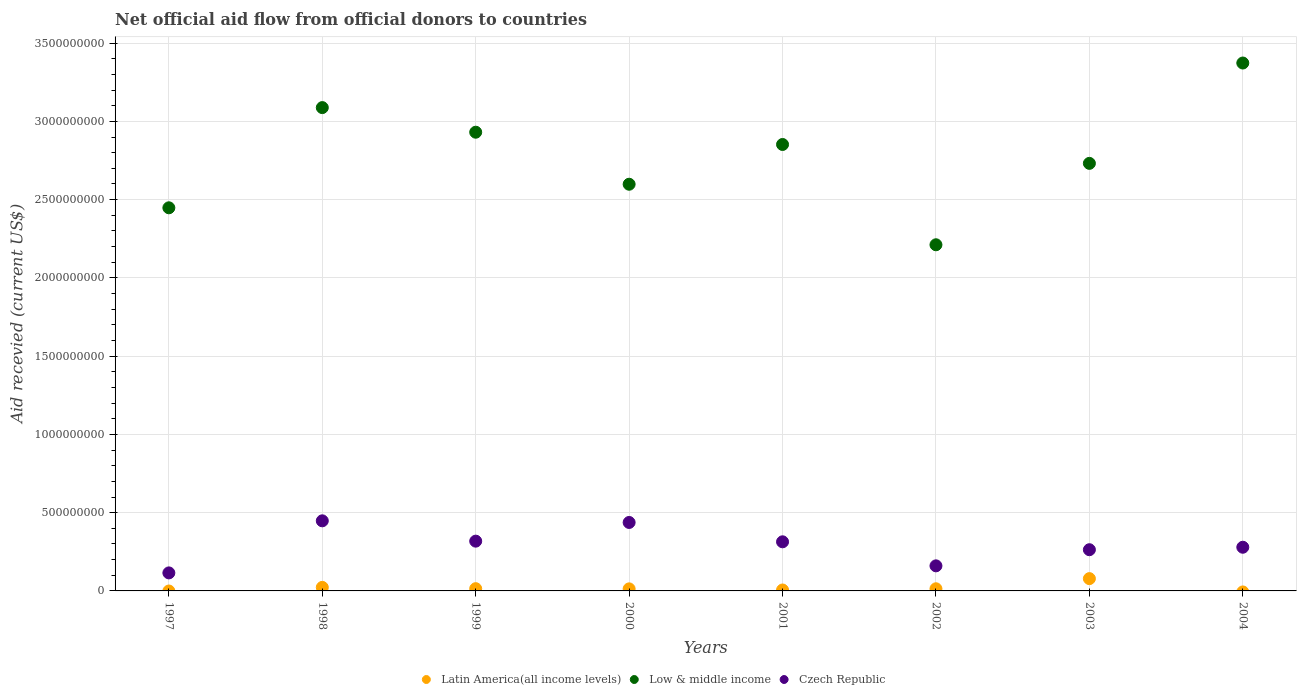How many different coloured dotlines are there?
Your answer should be compact. 3. Is the number of dotlines equal to the number of legend labels?
Your response must be concise. No. What is the total aid received in Low & middle income in 1998?
Provide a short and direct response. 3.09e+09. Across all years, what is the maximum total aid received in Low & middle income?
Make the answer very short. 3.37e+09. Across all years, what is the minimum total aid received in Czech Republic?
Give a very brief answer. 1.15e+08. In which year was the total aid received in Latin America(all income levels) maximum?
Offer a terse response. 2003. What is the total total aid received in Low & middle income in the graph?
Your response must be concise. 2.22e+1. What is the difference between the total aid received in Czech Republic in 1997 and that in 2003?
Your answer should be compact. -1.48e+08. What is the difference between the total aid received in Czech Republic in 2003 and the total aid received in Latin America(all income levels) in 1997?
Your answer should be very brief. 2.63e+08. What is the average total aid received in Czech Republic per year?
Ensure brevity in your answer.  2.92e+08. In the year 1998, what is the difference between the total aid received in Czech Republic and total aid received in Low & middle income?
Offer a very short reply. -2.64e+09. In how many years, is the total aid received in Low & middle income greater than 1800000000 US$?
Ensure brevity in your answer.  8. What is the ratio of the total aid received in Low & middle income in 2001 to that in 2002?
Your answer should be very brief. 1.29. Is the difference between the total aid received in Czech Republic in 1999 and 2000 greater than the difference between the total aid received in Low & middle income in 1999 and 2000?
Offer a very short reply. No. What is the difference between the highest and the second highest total aid received in Czech Republic?
Give a very brief answer. 1.05e+07. What is the difference between the highest and the lowest total aid received in Low & middle income?
Provide a short and direct response. 1.16e+09. In how many years, is the total aid received in Czech Republic greater than the average total aid received in Czech Republic taken over all years?
Provide a short and direct response. 4. Is the total aid received in Czech Republic strictly greater than the total aid received in Latin America(all income levels) over the years?
Provide a succinct answer. Yes. Is the total aid received in Czech Republic strictly less than the total aid received in Low & middle income over the years?
Give a very brief answer. Yes. Does the graph contain grids?
Your answer should be compact. Yes. Where does the legend appear in the graph?
Provide a short and direct response. Bottom center. What is the title of the graph?
Give a very brief answer. Net official aid flow from official donors to countries. Does "Kazakhstan" appear as one of the legend labels in the graph?
Keep it short and to the point. No. What is the label or title of the Y-axis?
Your response must be concise. Aid recevied (current US$). What is the Aid recevied (current US$) in Latin America(all income levels) in 1997?
Give a very brief answer. 0. What is the Aid recevied (current US$) in Low & middle income in 1997?
Ensure brevity in your answer.  2.45e+09. What is the Aid recevied (current US$) in Czech Republic in 1997?
Offer a terse response. 1.15e+08. What is the Aid recevied (current US$) of Latin America(all income levels) in 1998?
Your response must be concise. 2.25e+07. What is the Aid recevied (current US$) of Low & middle income in 1998?
Your answer should be very brief. 3.09e+09. What is the Aid recevied (current US$) of Czech Republic in 1998?
Ensure brevity in your answer.  4.48e+08. What is the Aid recevied (current US$) in Latin America(all income levels) in 1999?
Your answer should be compact. 1.43e+07. What is the Aid recevied (current US$) of Low & middle income in 1999?
Your answer should be compact. 2.93e+09. What is the Aid recevied (current US$) in Czech Republic in 1999?
Provide a short and direct response. 3.18e+08. What is the Aid recevied (current US$) in Latin America(all income levels) in 2000?
Give a very brief answer. 1.31e+07. What is the Aid recevied (current US$) of Low & middle income in 2000?
Your response must be concise. 2.60e+09. What is the Aid recevied (current US$) in Czech Republic in 2000?
Your response must be concise. 4.37e+08. What is the Aid recevied (current US$) in Latin America(all income levels) in 2001?
Offer a terse response. 5.97e+06. What is the Aid recevied (current US$) in Low & middle income in 2001?
Ensure brevity in your answer.  2.85e+09. What is the Aid recevied (current US$) of Czech Republic in 2001?
Keep it short and to the point. 3.14e+08. What is the Aid recevied (current US$) of Latin America(all income levels) in 2002?
Your answer should be very brief. 1.37e+07. What is the Aid recevied (current US$) in Low & middle income in 2002?
Keep it short and to the point. 2.21e+09. What is the Aid recevied (current US$) in Czech Republic in 2002?
Keep it short and to the point. 1.60e+08. What is the Aid recevied (current US$) of Latin America(all income levels) in 2003?
Offer a terse response. 7.86e+07. What is the Aid recevied (current US$) in Low & middle income in 2003?
Your answer should be compact. 2.73e+09. What is the Aid recevied (current US$) in Czech Republic in 2003?
Your response must be concise. 2.63e+08. What is the Aid recevied (current US$) in Latin America(all income levels) in 2004?
Your response must be concise. 0. What is the Aid recevied (current US$) of Low & middle income in 2004?
Offer a very short reply. 3.37e+09. What is the Aid recevied (current US$) in Czech Republic in 2004?
Offer a terse response. 2.79e+08. Across all years, what is the maximum Aid recevied (current US$) of Latin America(all income levels)?
Make the answer very short. 7.86e+07. Across all years, what is the maximum Aid recevied (current US$) in Low & middle income?
Give a very brief answer. 3.37e+09. Across all years, what is the maximum Aid recevied (current US$) in Czech Republic?
Your answer should be very brief. 4.48e+08. Across all years, what is the minimum Aid recevied (current US$) of Low & middle income?
Provide a short and direct response. 2.21e+09. Across all years, what is the minimum Aid recevied (current US$) in Czech Republic?
Keep it short and to the point. 1.15e+08. What is the total Aid recevied (current US$) in Latin America(all income levels) in the graph?
Give a very brief answer. 1.48e+08. What is the total Aid recevied (current US$) in Low & middle income in the graph?
Your answer should be compact. 2.22e+1. What is the total Aid recevied (current US$) in Czech Republic in the graph?
Your response must be concise. 2.33e+09. What is the difference between the Aid recevied (current US$) in Low & middle income in 1997 and that in 1998?
Offer a terse response. -6.40e+08. What is the difference between the Aid recevied (current US$) of Czech Republic in 1997 and that in 1998?
Offer a terse response. -3.33e+08. What is the difference between the Aid recevied (current US$) in Low & middle income in 1997 and that in 1999?
Keep it short and to the point. -4.83e+08. What is the difference between the Aid recevied (current US$) of Czech Republic in 1997 and that in 1999?
Offer a terse response. -2.03e+08. What is the difference between the Aid recevied (current US$) in Low & middle income in 1997 and that in 2000?
Offer a terse response. -1.50e+08. What is the difference between the Aid recevied (current US$) of Czech Republic in 1997 and that in 2000?
Provide a succinct answer. -3.22e+08. What is the difference between the Aid recevied (current US$) in Low & middle income in 1997 and that in 2001?
Provide a succinct answer. -4.04e+08. What is the difference between the Aid recevied (current US$) of Czech Republic in 1997 and that in 2001?
Provide a succinct answer. -1.99e+08. What is the difference between the Aid recevied (current US$) in Low & middle income in 1997 and that in 2002?
Give a very brief answer. 2.36e+08. What is the difference between the Aid recevied (current US$) of Czech Republic in 1997 and that in 2002?
Give a very brief answer. -4.51e+07. What is the difference between the Aid recevied (current US$) of Low & middle income in 1997 and that in 2003?
Provide a short and direct response. -2.84e+08. What is the difference between the Aid recevied (current US$) of Czech Republic in 1997 and that in 2003?
Your response must be concise. -1.48e+08. What is the difference between the Aid recevied (current US$) in Low & middle income in 1997 and that in 2004?
Your response must be concise. -9.25e+08. What is the difference between the Aid recevied (current US$) in Czech Republic in 1997 and that in 2004?
Keep it short and to the point. -1.64e+08. What is the difference between the Aid recevied (current US$) in Latin America(all income levels) in 1998 and that in 1999?
Your answer should be compact. 8.20e+06. What is the difference between the Aid recevied (current US$) in Low & middle income in 1998 and that in 1999?
Ensure brevity in your answer.  1.57e+08. What is the difference between the Aid recevied (current US$) in Czech Republic in 1998 and that in 1999?
Provide a succinct answer. 1.30e+08. What is the difference between the Aid recevied (current US$) in Latin America(all income levels) in 1998 and that in 2000?
Provide a succinct answer. 9.40e+06. What is the difference between the Aid recevied (current US$) in Low & middle income in 1998 and that in 2000?
Your answer should be very brief. 4.90e+08. What is the difference between the Aid recevied (current US$) of Czech Republic in 1998 and that in 2000?
Make the answer very short. 1.05e+07. What is the difference between the Aid recevied (current US$) of Latin America(all income levels) in 1998 and that in 2001?
Offer a terse response. 1.66e+07. What is the difference between the Aid recevied (current US$) of Low & middle income in 1998 and that in 2001?
Your response must be concise. 2.36e+08. What is the difference between the Aid recevied (current US$) in Czech Republic in 1998 and that in 2001?
Make the answer very short. 1.34e+08. What is the difference between the Aid recevied (current US$) of Latin America(all income levels) in 1998 and that in 2002?
Make the answer very short. 8.82e+06. What is the difference between the Aid recevied (current US$) in Low & middle income in 1998 and that in 2002?
Give a very brief answer. 8.76e+08. What is the difference between the Aid recevied (current US$) of Czech Republic in 1998 and that in 2002?
Your answer should be very brief. 2.88e+08. What is the difference between the Aid recevied (current US$) in Latin America(all income levels) in 1998 and that in 2003?
Keep it short and to the point. -5.60e+07. What is the difference between the Aid recevied (current US$) in Low & middle income in 1998 and that in 2003?
Your answer should be compact. 3.56e+08. What is the difference between the Aid recevied (current US$) of Czech Republic in 1998 and that in 2003?
Your answer should be very brief. 1.85e+08. What is the difference between the Aid recevied (current US$) of Low & middle income in 1998 and that in 2004?
Keep it short and to the point. -2.85e+08. What is the difference between the Aid recevied (current US$) of Czech Republic in 1998 and that in 2004?
Your response must be concise. 1.69e+08. What is the difference between the Aid recevied (current US$) of Latin America(all income levels) in 1999 and that in 2000?
Ensure brevity in your answer.  1.20e+06. What is the difference between the Aid recevied (current US$) in Low & middle income in 1999 and that in 2000?
Your response must be concise. 3.32e+08. What is the difference between the Aid recevied (current US$) of Czech Republic in 1999 and that in 2000?
Offer a very short reply. -1.19e+08. What is the difference between the Aid recevied (current US$) of Latin America(all income levels) in 1999 and that in 2001?
Offer a very short reply. 8.36e+06. What is the difference between the Aid recevied (current US$) in Low & middle income in 1999 and that in 2001?
Make the answer very short. 7.84e+07. What is the difference between the Aid recevied (current US$) of Czech Republic in 1999 and that in 2001?
Provide a succinct answer. 4.21e+06. What is the difference between the Aid recevied (current US$) of Latin America(all income levels) in 1999 and that in 2002?
Keep it short and to the point. 6.20e+05. What is the difference between the Aid recevied (current US$) in Low & middle income in 1999 and that in 2002?
Provide a succinct answer. 7.19e+08. What is the difference between the Aid recevied (current US$) of Czech Republic in 1999 and that in 2002?
Provide a short and direct response. 1.58e+08. What is the difference between the Aid recevied (current US$) of Latin America(all income levels) in 1999 and that in 2003?
Make the answer very short. -6.42e+07. What is the difference between the Aid recevied (current US$) in Low & middle income in 1999 and that in 2003?
Make the answer very short. 1.99e+08. What is the difference between the Aid recevied (current US$) of Czech Republic in 1999 and that in 2003?
Your response must be concise. 5.47e+07. What is the difference between the Aid recevied (current US$) in Low & middle income in 1999 and that in 2004?
Make the answer very short. -4.42e+08. What is the difference between the Aid recevied (current US$) of Czech Republic in 1999 and that in 2004?
Keep it short and to the point. 3.89e+07. What is the difference between the Aid recevied (current US$) in Latin America(all income levels) in 2000 and that in 2001?
Ensure brevity in your answer.  7.16e+06. What is the difference between the Aid recevied (current US$) of Low & middle income in 2000 and that in 2001?
Make the answer very short. -2.54e+08. What is the difference between the Aid recevied (current US$) of Czech Republic in 2000 and that in 2001?
Your answer should be compact. 1.24e+08. What is the difference between the Aid recevied (current US$) of Latin America(all income levels) in 2000 and that in 2002?
Your answer should be compact. -5.80e+05. What is the difference between the Aid recevied (current US$) of Low & middle income in 2000 and that in 2002?
Your answer should be very brief. 3.87e+08. What is the difference between the Aid recevied (current US$) of Czech Republic in 2000 and that in 2002?
Provide a succinct answer. 2.77e+08. What is the difference between the Aid recevied (current US$) of Latin America(all income levels) in 2000 and that in 2003?
Give a very brief answer. -6.54e+07. What is the difference between the Aid recevied (current US$) in Low & middle income in 2000 and that in 2003?
Your answer should be compact. -1.33e+08. What is the difference between the Aid recevied (current US$) in Czech Republic in 2000 and that in 2003?
Ensure brevity in your answer.  1.74e+08. What is the difference between the Aid recevied (current US$) in Low & middle income in 2000 and that in 2004?
Offer a very short reply. -7.74e+08. What is the difference between the Aid recevied (current US$) in Czech Republic in 2000 and that in 2004?
Your answer should be very brief. 1.58e+08. What is the difference between the Aid recevied (current US$) in Latin America(all income levels) in 2001 and that in 2002?
Give a very brief answer. -7.74e+06. What is the difference between the Aid recevied (current US$) in Low & middle income in 2001 and that in 2002?
Your response must be concise. 6.41e+08. What is the difference between the Aid recevied (current US$) of Czech Republic in 2001 and that in 2002?
Offer a terse response. 1.54e+08. What is the difference between the Aid recevied (current US$) in Latin America(all income levels) in 2001 and that in 2003?
Provide a short and direct response. -7.26e+07. What is the difference between the Aid recevied (current US$) of Low & middle income in 2001 and that in 2003?
Provide a succinct answer. 1.21e+08. What is the difference between the Aid recevied (current US$) of Czech Republic in 2001 and that in 2003?
Your answer should be very brief. 5.05e+07. What is the difference between the Aid recevied (current US$) in Low & middle income in 2001 and that in 2004?
Ensure brevity in your answer.  -5.20e+08. What is the difference between the Aid recevied (current US$) in Czech Republic in 2001 and that in 2004?
Ensure brevity in your answer.  3.47e+07. What is the difference between the Aid recevied (current US$) in Latin America(all income levels) in 2002 and that in 2003?
Offer a terse response. -6.49e+07. What is the difference between the Aid recevied (current US$) of Low & middle income in 2002 and that in 2003?
Your answer should be very brief. -5.20e+08. What is the difference between the Aid recevied (current US$) in Czech Republic in 2002 and that in 2003?
Offer a terse response. -1.03e+08. What is the difference between the Aid recevied (current US$) of Low & middle income in 2002 and that in 2004?
Offer a terse response. -1.16e+09. What is the difference between the Aid recevied (current US$) of Czech Republic in 2002 and that in 2004?
Give a very brief answer. -1.19e+08. What is the difference between the Aid recevied (current US$) of Low & middle income in 2003 and that in 2004?
Your answer should be compact. -6.41e+08. What is the difference between the Aid recevied (current US$) of Czech Republic in 2003 and that in 2004?
Your response must be concise. -1.58e+07. What is the difference between the Aid recevied (current US$) in Low & middle income in 1997 and the Aid recevied (current US$) in Czech Republic in 1998?
Offer a terse response. 2.00e+09. What is the difference between the Aid recevied (current US$) in Low & middle income in 1997 and the Aid recevied (current US$) in Czech Republic in 1999?
Keep it short and to the point. 2.13e+09. What is the difference between the Aid recevied (current US$) in Low & middle income in 1997 and the Aid recevied (current US$) in Czech Republic in 2000?
Your answer should be very brief. 2.01e+09. What is the difference between the Aid recevied (current US$) of Low & middle income in 1997 and the Aid recevied (current US$) of Czech Republic in 2001?
Give a very brief answer. 2.13e+09. What is the difference between the Aid recevied (current US$) of Low & middle income in 1997 and the Aid recevied (current US$) of Czech Republic in 2002?
Offer a terse response. 2.29e+09. What is the difference between the Aid recevied (current US$) in Low & middle income in 1997 and the Aid recevied (current US$) in Czech Republic in 2003?
Offer a very short reply. 2.18e+09. What is the difference between the Aid recevied (current US$) in Low & middle income in 1997 and the Aid recevied (current US$) in Czech Republic in 2004?
Make the answer very short. 2.17e+09. What is the difference between the Aid recevied (current US$) in Latin America(all income levels) in 1998 and the Aid recevied (current US$) in Low & middle income in 1999?
Provide a short and direct response. -2.91e+09. What is the difference between the Aid recevied (current US$) of Latin America(all income levels) in 1998 and the Aid recevied (current US$) of Czech Republic in 1999?
Ensure brevity in your answer.  -2.95e+08. What is the difference between the Aid recevied (current US$) in Low & middle income in 1998 and the Aid recevied (current US$) in Czech Republic in 1999?
Make the answer very short. 2.77e+09. What is the difference between the Aid recevied (current US$) of Latin America(all income levels) in 1998 and the Aid recevied (current US$) of Low & middle income in 2000?
Ensure brevity in your answer.  -2.58e+09. What is the difference between the Aid recevied (current US$) in Latin America(all income levels) in 1998 and the Aid recevied (current US$) in Czech Republic in 2000?
Make the answer very short. -4.15e+08. What is the difference between the Aid recevied (current US$) of Low & middle income in 1998 and the Aid recevied (current US$) of Czech Republic in 2000?
Your answer should be compact. 2.65e+09. What is the difference between the Aid recevied (current US$) in Latin America(all income levels) in 1998 and the Aid recevied (current US$) in Low & middle income in 2001?
Offer a very short reply. -2.83e+09. What is the difference between the Aid recevied (current US$) in Latin America(all income levels) in 1998 and the Aid recevied (current US$) in Czech Republic in 2001?
Give a very brief answer. -2.91e+08. What is the difference between the Aid recevied (current US$) of Low & middle income in 1998 and the Aid recevied (current US$) of Czech Republic in 2001?
Offer a very short reply. 2.77e+09. What is the difference between the Aid recevied (current US$) of Latin America(all income levels) in 1998 and the Aid recevied (current US$) of Low & middle income in 2002?
Provide a succinct answer. -2.19e+09. What is the difference between the Aid recevied (current US$) in Latin America(all income levels) in 1998 and the Aid recevied (current US$) in Czech Republic in 2002?
Make the answer very short. -1.38e+08. What is the difference between the Aid recevied (current US$) in Low & middle income in 1998 and the Aid recevied (current US$) in Czech Republic in 2002?
Your response must be concise. 2.93e+09. What is the difference between the Aid recevied (current US$) in Latin America(all income levels) in 1998 and the Aid recevied (current US$) in Low & middle income in 2003?
Make the answer very short. -2.71e+09. What is the difference between the Aid recevied (current US$) of Latin America(all income levels) in 1998 and the Aid recevied (current US$) of Czech Republic in 2003?
Keep it short and to the point. -2.41e+08. What is the difference between the Aid recevied (current US$) of Low & middle income in 1998 and the Aid recevied (current US$) of Czech Republic in 2003?
Provide a short and direct response. 2.82e+09. What is the difference between the Aid recevied (current US$) of Latin America(all income levels) in 1998 and the Aid recevied (current US$) of Low & middle income in 2004?
Your answer should be very brief. -3.35e+09. What is the difference between the Aid recevied (current US$) in Latin America(all income levels) in 1998 and the Aid recevied (current US$) in Czech Republic in 2004?
Make the answer very short. -2.57e+08. What is the difference between the Aid recevied (current US$) in Low & middle income in 1998 and the Aid recevied (current US$) in Czech Republic in 2004?
Your answer should be compact. 2.81e+09. What is the difference between the Aid recevied (current US$) of Latin America(all income levels) in 1999 and the Aid recevied (current US$) of Low & middle income in 2000?
Your response must be concise. -2.58e+09. What is the difference between the Aid recevied (current US$) in Latin America(all income levels) in 1999 and the Aid recevied (current US$) in Czech Republic in 2000?
Offer a very short reply. -4.23e+08. What is the difference between the Aid recevied (current US$) in Low & middle income in 1999 and the Aid recevied (current US$) in Czech Republic in 2000?
Offer a very short reply. 2.49e+09. What is the difference between the Aid recevied (current US$) in Latin America(all income levels) in 1999 and the Aid recevied (current US$) in Low & middle income in 2001?
Give a very brief answer. -2.84e+09. What is the difference between the Aid recevied (current US$) in Latin America(all income levels) in 1999 and the Aid recevied (current US$) in Czech Republic in 2001?
Ensure brevity in your answer.  -2.99e+08. What is the difference between the Aid recevied (current US$) of Low & middle income in 1999 and the Aid recevied (current US$) of Czech Republic in 2001?
Give a very brief answer. 2.62e+09. What is the difference between the Aid recevied (current US$) of Latin America(all income levels) in 1999 and the Aid recevied (current US$) of Low & middle income in 2002?
Ensure brevity in your answer.  -2.20e+09. What is the difference between the Aid recevied (current US$) of Latin America(all income levels) in 1999 and the Aid recevied (current US$) of Czech Republic in 2002?
Give a very brief answer. -1.46e+08. What is the difference between the Aid recevied (current US$) in Low & middle income in 1999 and the Aid recevied (current US$) in Czech Republic in 2002?
Offer a terse response. 2.77e+09. What is the difference between the Aid recevied (current US$) in Latin America(all income levels) in 1999 and the Aid recevied (current US$) in Low & middle income in 2003?
Make the answer very short. -2.72e+09. What is the difference between the Aid recevied (current US$) in Latin America(all income levels) in 1999 and the Aid recevied (current US$) in Czech Republic in 2003?
Ensure brevity in your answer.  -2.49e+08. What is the difference between the Aid recevied (current US$) in Low & middle income in 1999 and the Aid recevied (current US$) in Czech Republic in 2003?
Ensure brevity in your answer.  2.67e+09. What is the difference between the Aid recevied (current US$) in Latin America(all income levels) in 1999 and the Aid recevied (current US$) in Low & middle income in 2004?
Give a very brief answer. -3.36e+09. What is the difference between the Aid recevied (current US$) of Latin America(all income levels) in 1999 and the Aid recevied (current US$) of Czech Republic in 2004?
Make the answer very short. -2.65e+08. What is the difference between the Aid recevied (current US$) of Low & middle income in 1999 and the Aid recevied (current US$) of Czech Republic in 2004?
Provide a short and direct response. 2.65e+09. What is the difference between the Aid recevied (current US$) of Latin America(all income levels) in 2000 and the Aid recevied (current US$) of Low & middle income in 2001?
Your response must be concise. -2.84e+09. What is the difference between the Aid recevied (current US$) in Latin America(all income levels) in 2000 and the Aid recevied (current US$) in Czech Republic in 2001?
Your answer should be very brief. -3.01e+08. What is the difference between the Aid recevied (current US$) of Low & middle income in 2000 and the Aid recevied (current US$) of Czech Republic in 2001?
Keep it short and to the point. 2.28e+09. What is the difference between the Aid recevied (current US$) of Latin America(all income levels) in 2000 and the Aid recevied (current US$) of Low & middle income in 2002?
Offer a terse response. -2.20e+09. What is the difference between the Aid recevied (current US$) of Latin America(all income levels) in 2000 and the Aid recevied (current US$) of Czech Republic in 2002?
Provide a succinct answer. -1.47e+08. What is the difference between the Aid recevied (current US$) in Low & middle income in 2000 and the Aid recevied (current US$) in Czech Republic in 2002?
Provide a succinct answer. 2.44e+09. What is the difference between the Aid recevied (current US$) of Latin America(all income levels) in 2000 and the Aid recevied (current US$) of Low & middle income in 2003?
Provide a succinct answer. -2.72e+09. What is the difference between the Aid recevied (current US$) in Latin America(all income levels) in 2000 and the Aid recevied (current US$) in Czech Republic in 2003?
Make the answer very short. -2.50e+08. What is the difference between the Aid recevied (current US$) of Low & middle income in 2000 and the Aid recevied (current US$) of Czech Republic in 2003?
Your response must be concise. 2.34e+09. What is the difference between the Aid recevied (current US$) in Latin America(all income levels) in 2000 and the Aid recevied (current US$) in Low & middle income in 2004?
Give a very brief answer. -3.36e+09. What is the difference between the Aid recevied (current US$) of Latin America(all income levels) in 2000 and the Aid recevied (current US$) of Czech Republic in 2004?
Your response must be concise. -2.66e+08. What is the difference between the Aid recevied (current US$) of Low & middle income in 2000 and the Aid recevied (current US$) of Czech Republic in 2004?
Make the answer very short. 2.32e+09. What is the difference between the Aid recevied (current US$) in Latin America(all income levels) in 2001 and the Aid recevied (current US$) in Low & middle income in 2002?
Offer a terse response. -2.21e+09. What is the difference between the Aid recevied (current US$) in Latin America(all income levels) in 2001 and the Aid recevied (current US$) in Czech Republic in 2002?
Provide a short and direct response. -1.54e+08. What is the difference between the Aid recevied (current US$) in Low & middle income in 2001 and the Aid recevied (current US$) in Czech Republic in 2002?
Your response must be concise. 2.69e+09. What is the difference between the Aid recevied (current US$) in Latin America(all income levels) in 2001 and the Aid recevied (current US$) in Low & middle income in 2003?
Your response must be concise. -2.73e+09. What is the difference between the Aid recevied (current US$) of Latin America(all income levels) in 2001 and the Aid recevied (current US$) of Czech Republic in 2003?
Provide a succinct answer. -2.57e+08. What is the difference between the Aid recevied (current US$) of Low & middle income in 2001 and the Aid recevied (current US$) of Czech Republic in 2003?
Keep it short and to the point. 2.59e+09. What is the difference between the Aid recevied (current US$) in Latin America(all income levels) in 2001 and the Aid recevied (current US$) in Low & middle income in 2004?
Provide a succinct answer. -3.37e+09. What is the difference between the Aid recevied (current US$) of Latin America(all income levels) in 2001 and the Aid recevied (current US$) of Czech Republic in 2004?
Offer a very short reply. -2.73e+08. What is the difference between the Aid recevied (current US$) in Low & middle income in 2001 and the Aid recevied (current US$) in Czech Republic in 2004?
Offer a terse response. 2.57e+09. What is the difference between the Aid recevied (current US$) in Latin America(all income levels) in 2002 and the Aid recevied (current US$) in Low & middle income in 2003?
Make the answer very short. -2.72e+09. What is the difference between the Aid recevied (current US$) of Latin America(all income levels) in 2002 and the Aid recevied (current US$) of Czech Republic in 2003?
Give a very brief answer. -2.50e+08. What is the difference between the Aid recevied (current US$) in Low & middle income in 2002 and the Aid recevied (current US$) in Czech Republic in 2003?
Provide a succinct answer. 1.95e+09. What is the difference between the Aid recevied (current US$) in Latin America(all income levels) in 2002 and the Aid recevied (current US$) in Low & middle income in 2004?
Make the answer very short. -3.36e+09. What is the difference between the Aid recevied (current US$) of Latin America(all income levels) in 2002 and the Aid recevied (current US$) of Czech Republic in 2004?
Your answer should be very brief. -2.65e+08. What is the difference between the Aid recevied (current US$) in Low & middle income in 2002 and the Aid recevied (current US$) in Czech Republic in 2004?
Offer a very short reply. 1.93e+09. What is the difference between the Aid recevied (current US$) in Latin America(all income levels) in 2003 and the Aid recevied (current US$) in Low & middle income in 2004?
Offer a very short reply. -3.29e+09. What is the difference between the Aid recevied (current US$) of Latin America(all income levels) in 2003 and the Aid recevied (current US$) of Czech Republic in 2004?
Provide a short and direct response. -2.00e+08. What is the difference between the Aid recevied (current US$) in Low & middle income in 2003 and the Aid recevied (current US$) in Czech Republic in 2004?
Provide a short and direct response. 2.45e+09. What is the average Aid recevied (current US$) in Latin America(all income levels) per year?
Offer a very short reply. 1.85e+07. What is the average Aid recevied (current US$) of Low & middle income per year?
Ensure brevity in your answer.  2.78e+09. What is the average Aid recevied (current US$) in Czech Republic per year?
Offer a terse response. 2.92e+08. In the year 1997, what is the difference between the Aid recevied (current US$) of Low & middle income and Aid recevied (current US$) of Czech Republic?
Your response must be concise. 2.33e+09. In the year 1998, what is the difference between the Aid recevied (current US$) of Latin America(all income levels) and Aid recevied (current US$) of Low & middle income?
Your answer should be very brief. -3.07e+09. In the year 1998, what is the difference between the Aid recevied (current US$) in Latin America(all income levels) and Aid recevied (current US$) in Czech Republic?
Your response must be concise. -4.25e+08. In the year 1998, what is the difference between the Aid recevied (current US$) of Low & middle income and Aid recevied (current US$) of Czech Republic?
Offer a terse response. 2.64e+09. In the year 1999, what is the difference between the Aid recevied (current US$) in Latin America(all income levels) and Aid recevied (current US$) in Low & middle income?
Provide a short and direct response. -2.92e+09. In the year 1999, what is the difference between the Aid recevied (current US$) in Latin America(all income levels) and Aid recevied (current US$) in Czech Republic?
Provide a succinct answer. -3.04e+08. In the year 1999, what is the difference between the Aid recevied (current US$) in Low & middle income and Aid recevied (current US$) in Czech Republic?
Give a very brief answer. 2.61e+09. In the year 2000, what is the difference between the Aid recevied (current US$) of Latin America(all income levels) and Aid recevied (current US$) of Low & middle income?
Your answer should be very brief. -2.59e+09. In the year 2000, what is the difference between the Aid recevied (current US$) in Latin America(all income levels) and Aid recevied (current US$) in Czech Republic?
Ensure brevity in your answer.  -4.24e+08. In the year 2000, what is the difference between the Aid recevied (current US$) of Low & middle income and Aid recevied (current US$) of Czech Republic?
Make the answer very short. 2.16e+09. In the year 2001, what is the difference between the Aid recevied (current US$) in Latin America(all income levels) and Aid recevied (current US$) in Low & middle income?
Your response must be concise. -2.85e+09. In the year 2001, what is the difference between the Aid recevied (current US$) in Latin America(all income levels) and Aid recevied (current US$) in Czech Republic?
Offer a terse response. -3.08e+08. In the year 2001, what is the difference between the Aid recevied (current US$) in Low & middle income and Aid recevied (current US$) in Czech Republic?
Ensure brevity in your answer.  2.54e+09. In the year 2002, what is the difference between the Aid recevied (current US$) of Latin America(all income levels) and Aid recevied (current US$) of Low & middle income?
Offer a very short reply. -2.20e+09. In the year 2002, what is the difference between the Aid recevied (current US$) of Latin America(all income levels) and Aid recevied (current US$) of Czech Republic?
Keep it short and to the point. -1.46e+08. In the year 2002, what is the difference between the Aid recevied (current US$) of Low & middle income and Aid recevied (current US$) of Czech Republic?
Make the answer very short. 2.05e+09. In the year 2003, what is the difference between the Aid recevied (current US$) of Latin America(all income levels) and Aid recevied (current US$) of Low & middle income?
Your answer should be compact. -2.65e+09. In the year 2003, what is the difference between the Aid recevied (current US$) in Latin America(all income levels) and Aid recevied (current US$) in Czech Republic?
Your answer should be very brief. -1.85e+08. In the year 2003, what is the difference between the Aid recevied (current US$) in Low & middle income and Aid recevied (current US$) in Czech Republic?
Your answer should be compact. 2.47e+09. In the year 2004, what is the difference between the Aid recevied (current US$) in Low & middle income and Aid recevied (current US$) in Czech Republic?
Offer a terse response. 3.09e+09. What is the ratio of the Aid recevied (current US$) of Low & middle income in 1997 to that in 1998?
Ensure brevity in your answer.  0.79. What is the ratio of the Aid recevied (current US$) of Czech Republic in 1997 to that in 1998?
Make the answer very short. 0.26. What is the ratio of the Aid recevied (current US$) of Low & middle income in 1997 to that in 1999?
Provide a short and direct response. 0.84. What is the ratio of the Aid recevied (current US$) of Czech Republic in 1997 to that in 1999?
Your response must be concise. 0.36. What is the ratio of the Aid recevied (current US$) of Low & middle income in 1997 to that in 2000?
Provide a succinct answer. 0.94. What is the ratio of the Aid recevied (current US$) of Czech Republic in 1997 to that in 2000?
Your response must be concise. 0.26. What is the ratio of the Aid recevied (current US$) in Low & middle income in 1997 to that in 2001?
Offer a very short reply. 0.86. What is the ratio of the Aid recevied (current US$) of Czech Republic in 1997 to that in 2001?
Give a very brief answer. 0.37. What is the ratio of the Aid recevied (current US$) in Low & middle income in 1997 to that in 2002?
Your answer should be very brief. 1.11. What is the ratio of the Aid recevied (current US$) of Czech Republic in 1997 to that in 2002?
Your response must be concise. 0.72. What is the ratio of the Aid recevied (current US$) of Low & middle income in 1997 to that in 2003?
Make the answer very short. 0.9. What is the ratio of the Aid recevied (current US$) in Czech Republic in 1997 to that in 2003?
Offer a terse response. 0.44. What is the ratio of the Aid recevied (current US$) of Low & middle income in 1997 to that in 2004?
Provide a short and direct response. 0.73. What is the ratio of the Aid recevied (current US$) of Czech Republic in 1997 to that in 2004?
Provide a short and direct response. 0.41. What is the ratio of the Aid recevied (current US$) in Latin America(all income levels) in 1998 to that in 1999?
Offer a terse response. 1.57. What is the ratio of the Aid recevied (current US$) of Low & middle income in 1998 to that in 1999?
Ensure brevity in your answer.  1.05. What is the ratio of the Aid recevied (current US$) of Czech Republic in 1998 to that in 1999?
Keep it short and to the point. 1.41. What is the ratio of the Aid recevied (current US$) in Latin America(all income levels) in 1998 to that in 2000?
Offer a very short reply. 1.72. What is the ratio of the Aid recevied (current US$) in Low & middle income in 1998 to that in 2000?
Provide a short and direct response. 1.19. What is the ratio of the Aid recevied (current US$) in Czech Republic in 1998 to that in 2000?
Your answer should be very brief. 1.02. What is the ratio of the Aid recevied (current US$) of Latin America(all income levels) in 1998 to that in 2001?
Offer a terse response. 3.77. What is the ratio of the Aid recevied (current US$) in Low & middle income in 1998 to that in 2001?
Make the answer very short. 1.08. What is the ratio of the Aid recevied (current US$) in Czech Republic in 1998 to that in 2001?
Your answer should be compact. 1.43. What is the ratio of the Aid recevied (current US$) in Latin America(all income levels) in 1998 to that in 2002?
Give a very brief answer. 1.64. What is the ratio of the Aid recevied (current US$) in Low & middle income in 1998 to that in 2002?
Your answer should be compact. 1.4. What is the ratio of the Aid recevied (current US$) in Czech Republic in 1998 to that in 2002?
Your response must be concise. 2.8. What is the ratio of the Aid recevied (current US$) in Latin America(all income levels) in 1998 to that in 2003?
Make the answer very short. 0.29. What is the ratio of the Aid recevied (current US$) of Low & middle income in 1998 to that in 2003?
Provide a succinct answer. 1.13. What is the ratio of the Aid recevied (current US$) in Czech Republic in 1998 to that in 2003?
Your answer should be very brief. 1.7. What is the ratio of the Aid recevied (current US$) in Low & middle income in 1998 to that in 2004?
Offer a very short reply. 0.92. What is the ratio of the Aid recevied (current US$) of Czech Republic in 1998 to that in 2004?
Offer a very short reply. 1.6. What is the ratio of the Aid recevied (current US$) in Latin America(all income levels) in 1999 to that in 2000?
Provide a succinct answer. 1.09. What is the ratio of the Aid recevied (current US$) of Low & middle income in 1999 to that in 2000?
Offer a terse response. 1.13. What is the ratio of the Aid recevied (current US$) of Czech Republic in 1999 to that in 2000?
Give a very brief answer. 0.73. What is the ratio of the Aid recevied (current US$) in Latin America(all income levels) in 1999 to that in 2001?
Your answer should be very brief. 2.4. What is the ratio of the Aid recevied (current US$) of Low & middle income in 1999 to that in 2001?
Provide a short and direct response. 1.03. What is the ratio of the Aid recevied (current US$) in Czech Republic in 1999 to that in 2001?
Make the answer very short. 1.01. What is the ratio of the Aid recevied (current US$) of Latin America(all income levels) in 1999 to that in 2002?
Your response must be concise. 1.05. What is the ratio of the Aid recevied (current US$) of Low & middle income in 1999 to that in 2002?
Offer a terse response. 1.33. What is the ratio of the Aid recevied (current US$) in Czech Republic in 1999 to that in 2002?
Give a very brief answer. 1.98. What is the ratio of the Aid recevied (current US$) of Latin America(all income levels) in 1999 to that in 2003?
Keep it short and to the point. 0.18. What is the ratio of the Aid recevied (current US$) of Low & middle income in 1999 to that in 2003?
Offer a very short reply. 1.07. What is the ratio of the Aid recevied (current US$) in Czech Republic in 1999 to that in 2003?
Provide a succinct answer. 1.21. What is the ratio of the Aid recevied (current US$) of Low & middle income in 1999 to that in 2004?
Ensure brevity in your answer.  0.87. What is the ratio of the Aid recevied (current US$) in Czech Republic in 1999 to that in 2004?
Ensure brevity in your answer.  1.14. What is the ratio of the Aid recevied (current US$) of Latin America(all income levels) in 2000 to that in 2001?
Offer a very short reply. 2.2. What is the ratio of the Aid recevied (current US$) of Low & middle income in 2000 to that in 2001?
Make the answer very short. 0.91. What is the ratio of the Aid recevied (current US$) of Czech Republic in 2000 to that in 2001?
Make the answer very short. 1.39. What is the ratio of the Aid recevied (current US$) of Latin America(all income levels) in 2000 to that in 2002?
Provide a short and direct response. 0.96. What is the ratio of the Aid recevied (current US$) in Low & middle income in 2000 to that in 2002?
Your answer should be very brief. 1.17. What is the ratio of the Aid recevied (current US$) in Czech Republic in 2000 to that in 2002?
Give a very brief answer. 2.73. What is the ratio of the Aid recevied (current US$) of Latin America(all income levels) in 2000 to that in 2003?
Your response must be concise. 0.17. What is the ratio of the Aid recevied (current US$) in Low & middle income in 2000 to that in 2003?
Your answer should be very brief. 0.95. What is the ratio of the Aid recevied (current US$) in Czech Republic in 2000 to that in 2003?
Your response must be concise. 1.66. What is the ratio of the Aid recevied (current US$) of Low & middle income in 2000 to that in 2004?
Give a very brief answer. 0.77. What is the ratio of the Aid recevied (current US$) in Czech Republic in 2000 to that in 2004?
Provide a succinct answer. 1.57. What is the ratio of the Aid recevied (current US$) in Latin America(all income levels) in 2001 to that in 2002?
Your answer should be very brief. 0.44. What is the ratio of the Aid recevied (current US$) of Low & middle income in 2001 to that in 2002?
Your response must be concise. 1.29. What is the ratio of the Aid recevied (current US$) in Czech Republic in 2001 to that in 2002?
Provide a succinct answer. 1.96. What is the ratio of the Aid recevied (current US$) in Latin America(all income levels) in 2001 to that in 2003?
Provide a succinct answer. 0.08. What is the ratio of the Aid recevied (current US$) of Low & middle income in 2001 to that in 2003?
Give a very brief answer. 1.04. What is the ratio of the Aid recevied (current US$) of Czech Republic in 2001 to that in 2003?
Offer a very short reply. 1.19. What is the ratio of the Aid recevied (current US$) in Low & middle income in 2001 to that in 2004?
Make the answer very short. 0.85. What is the ratio of the Aid recevied (current US$) of Czech Republic in 2001 to that in 2004?
Give a very brief answer. 1.12. What is the ratio of the Aid recevied (current US$) in Latin America(all income levels) in 2002 to that in 2003?
Your answer should be very brief. 0.17. What is the ratio of the Aid recevied (current US$) of Low & middle income in 2002 to that in 2003?
Keep it short and to the point. 0.81. What is the ratio of the Aid recevied (current US$) of Czech Republic in 2002 to that in 2003?
Your answer should be compact. 0.61. What is the ratio of the Aid recevied (current US$) in Low & middle income in 2002 to that in 2004?
Provide a succinct answer. 0.66. What is the ratio of the Aid recevied (current US$) of Czech Republic in 2002 to that in 2004?
Your response must be concise. 0.57. What is the ratio of the Aid recevied (current US$) in Low & middle income in 2003 to that in 2004?
Offer a very short reply. 0.81. What is the ratio of the Aid recevied (current US$) in Czech Republic in 2003 to that in 2004?
Provide a short and direct response. 0.94. What is the difference between the highest and the second highest Aid recevied (current US$) in Latin America(all income levels)?
Keep it short and to the point. 5.60e+07. What is the difference between the highest and the second highest Aid recevied (current US$) of Low & middle income?
Ensure brevity in your answer.  2.85e+08. What is the difference between the highest and the second highest Aid recevied (current US$) in Czech Republic?
Your answer should be compact. 1.05e+07. What is the difference between the highest and the lowest Aid recevied (current US$) in Latin America(all income levels)?
Your answer should be compact. 7.86e+07. What is the difference between the highest and the lowest Aid recevied (current US$) in Low & middle income?
Your response must be concise. 1.16e+09. What is the difference between the highest and the lowest Aid recevied (current US$) in Czech Republic?
Keep it short and to the point. 3.33e+08. 